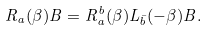<formula> <loc_0><loc_0><loc_500><loc_500>R _ { a } ( \beta ) B = R _ { a } ^ { b } ( \beta ) L _ { \bar { b } } ( - \beta ) B .</formula> 